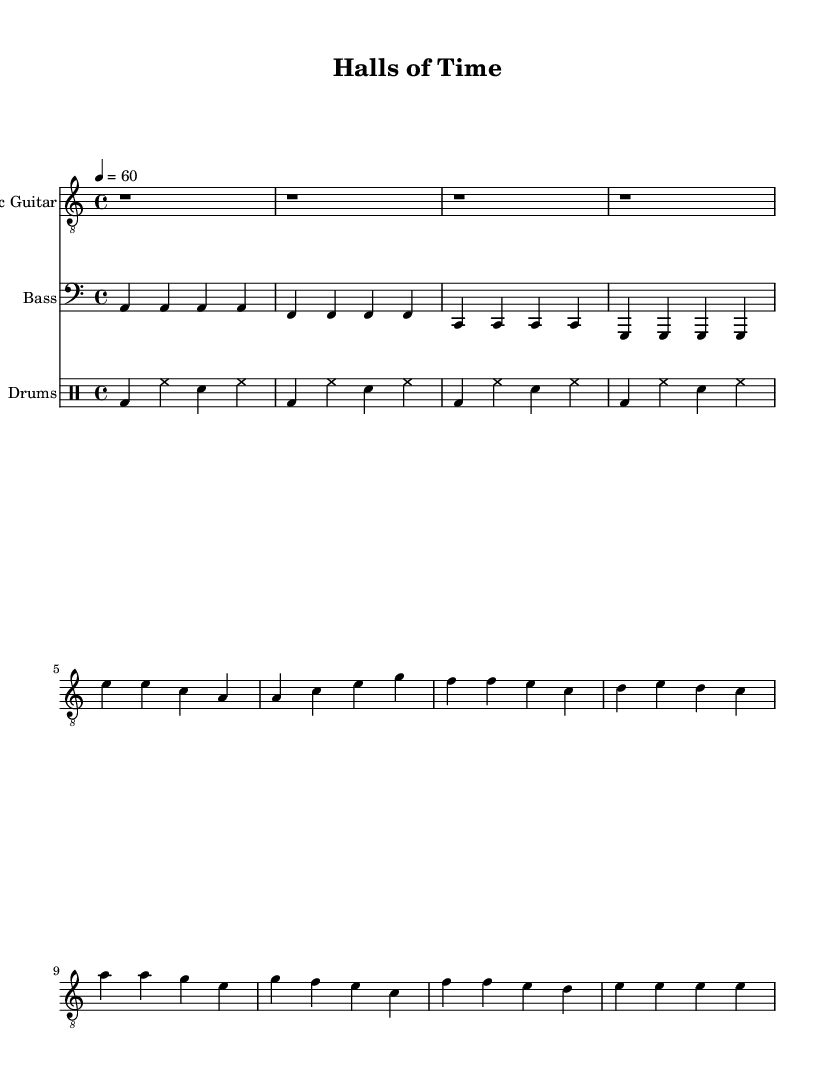What is the key signature of this music? The key signature is indicated in the beginning of the score as there are no sharps or flats present which corresponds to the notes played in the piece. The music is written in a minor key with one flat.
Answer: A minor What is the time signature of this music? The time signature is found at the beginning of the score, indicated as a fraction. The top number indicates how many beats are in a measure, and the bottom number indicates the note value that gets one beat. Here, it shows four beats per measure, which is common in blues music.
Answer: Four four What is the tempo of this music? The tempo is specified at the start of the score in beats per minute (BPM). The notation shows that the tempo is set to 60 BPM, indicating a slower and steady pace, typical for blues ballads.
Answer: 60 How many measures are there in the electric guitar part? By counting the sections of notes that appear before the next bar line, we can determine how many measures are present in the guitar staff. In this sheet music, the guitar part has a total of eight measures.
Answer: Eight Which instrument plays the bass notes? The instrument that plays the bass part is specified at the beginning of that staff. The bass clef indicates that the lower-pitched notes are played by a bass guitar. This reflects the role of bass in providing harmonic support in blues music.
Answer: Bass How does the verse relate to the chorus in terms of lyrical content? The verse introduces themes of searching for identity and the passage of time, while the chorus emphasizes personal growth and self-discovery. This progression illustrates a common narrative in coming-of-age stories through blues music, showcasing emotional depth and reflection.
Answer: Identity and growth What is the rhythmic pattern for the drums? The rhythmic pattern can be analyzed from the drum staff, where "bd" represents bass drum notes and "hh" represents hi-hat notes. The consistent pattern in the drum part follows a typical rock and blues style that uses steady beats.
Answer: Steady beats 